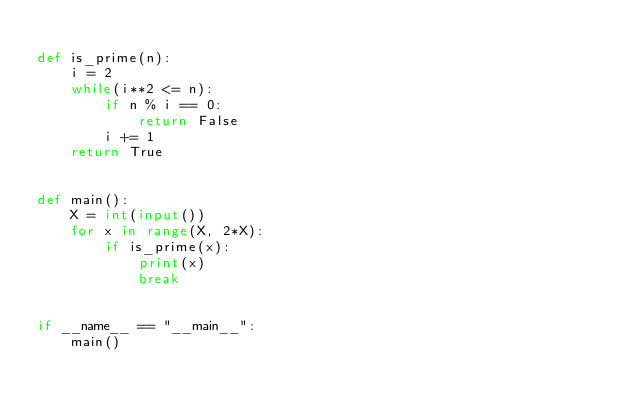Convert code to text. <code><loc_0><loc_0><loc_500><loc_500><_Python_>
def is_prime(n):
    i = 2
    while(i**2 <= n):
        if n % i == 0:
            return False
        i += 1
    return True


def main():
    X = int(input())
    for x in range(X, 2*X):
        if is_prime(x):
            print(x)
            break


if __name__ == "__main__":
    main()
</code> 